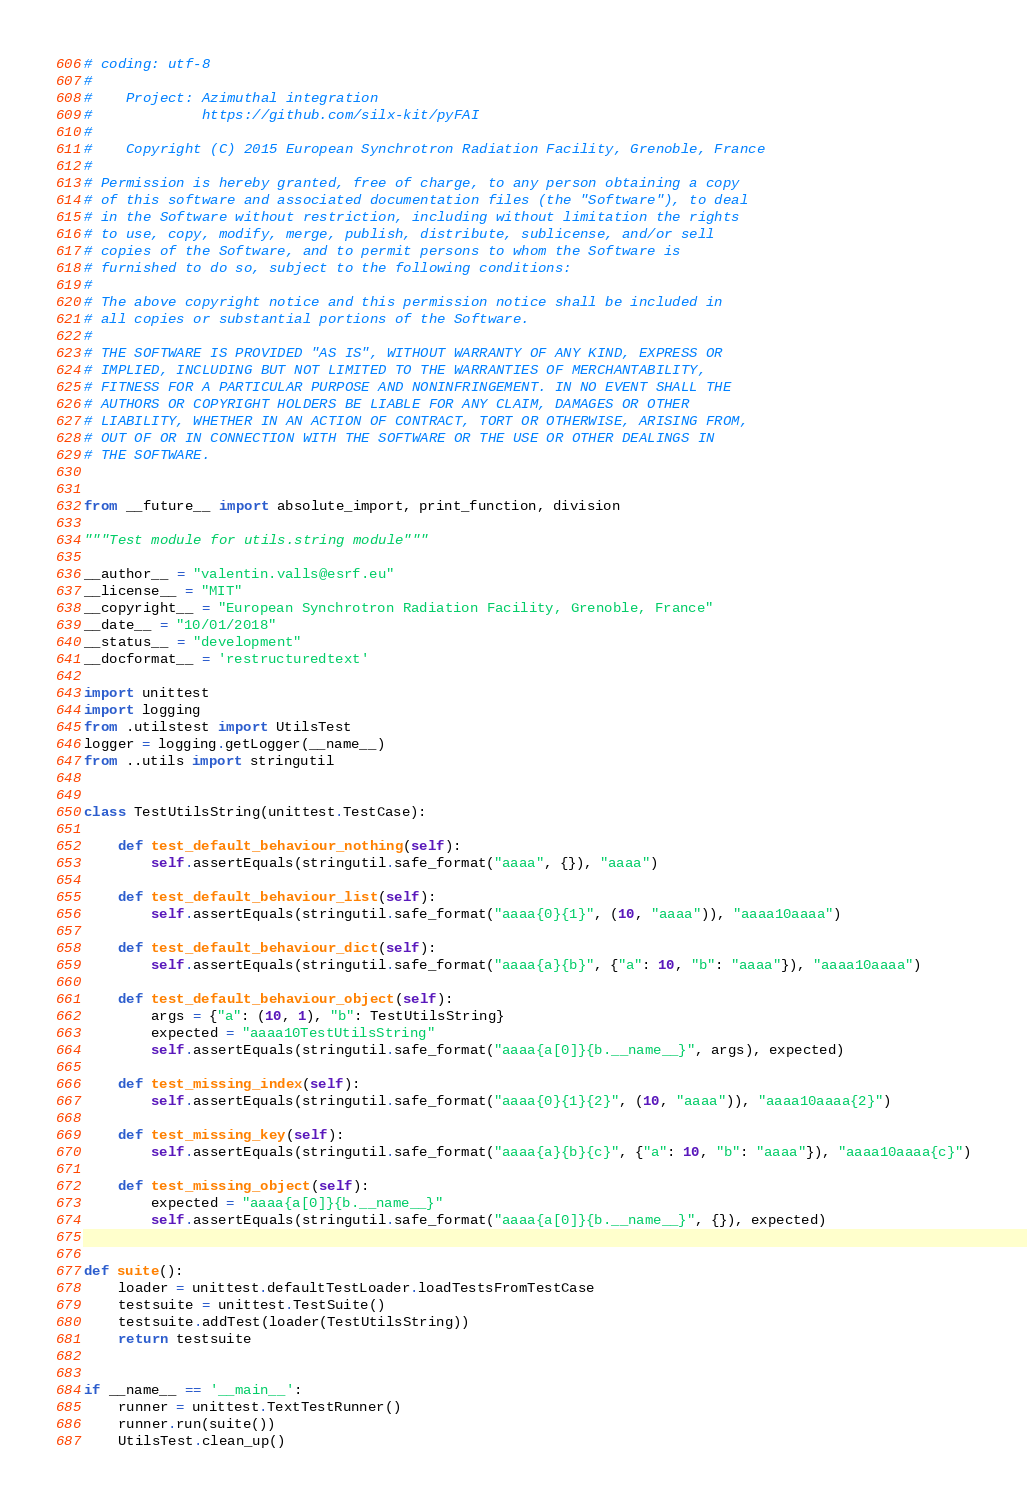Convert code to text. <code><loc_0><loc_0><loc_500><loc_500><_Python_># coding: utf-8
#
#    Project: Azimuthal integration
#             https://github.com/silx-kit/pyFAI
#
#    Copyright (C) 2015 European Synchrotron Radiation Facility, Grenoble, France
#
# Permission is hereby granted, free of charge, to any person obtaining a copy
# of this software and associated documentation files (the "Software"), to deal
# in the Software without restriction, including without limitation the rights
# to use, copy, modify, merge, publish, distribute, sublicense, and/or sell
# copies of the Software, and to permit persons to whom the Software is
# furnished to do so, subject to the following conditions:
#
# The above copyright notice and this permission notice shall be included in
# all copies or substantial portions of the Software.
#
# THE SOFTWARE IS PROVIDED "AS IS", WITHOUT WARRANTY OF ANY KIND, EXPRESS OR
# IMPLIED, INCLUDING BUT NOT LIMITED TO THE WARRANTIES OF MERCHANTABILITY,
# FITNESS FOR A PARTICULAR PURPOSE AND NONINFRINGEMENT. IN NO EVENT SHALL THE
# AUTHORS OR COPYRIGHT HOLDERS BE LIABLE FOR ANY CLAIM, DAMAGES OR OTHER
# LIABILITY, WHETHER IN AN ACTION OF CONTRACT, TORT OR OTHERWISE, ARISING FROM,
# OUT OF OR IN CONNECTION WITH THE SOFTWARE OR THE USE OR OTHER DEALINGS IN
# THE SOFTWARE.


from __future__ import absolute_import, print_function, division

"""Test module for utils.string module"""

__author__ = "valentin.valls@esrf.eu"
__license__ = "MIT"
__copyright__ = "European Synchrotron Radiation Facility, Grenoble, France"
__date__ = "10/01/2018"
__status__ = "development"
__docformat__ = 'restructuredtext'

import unittest
import logging
from .utilstest import UtilsTest
logger = logging.getLogger(__name__)
from ..utils import stringutil


class TestUtilsString(unittest.TestCase):

    def test_default_behaviour_nothing(self):
        self.assertEquals(stringutil.safe_format("aaaa", {}), "aaaa")

    def test_default_behaviour_list(self):
        self.assertEquals(stringutil.safe_format("aaaa{0}{1}", (10, "aaaa")), "aaaa10aaaa")

    def test_default_behaviour_dict(self):
        self.assertEquals(stringutil.safe_format("aaaa{a}{b}", {"a": 10, "b": "aaaa"}), "aaaa10aaaa")

    def test_default_behaviour_object(self):
        args = {"a": (10, 1), "b": TestUtilsString}
        expected = "aaaa10TestUtilsString"
        self.assertEquals(stringutil.safe_format("aaaa{a[0]}{b.__name__}", args), expected)

    def test_missing_index(self):
        self.assertEquals(stringutil.safe_format("aaaa{0}{1}{2}", (10, "aaaa")), "aaaa10aaaa{2}")

    def test_missing_key(self):
        self.assertEquals(stringutil.safe_format("aaaa{a}{b}{c}", {"a": 10, "b": "aaaa"}), "aaaa10aaaa{c}")

    def test_missing_object(self):
        expected = "aaaa{a[0]}{b.__name__}"
        self.assertEquals(stringutil.safe_format("aaaa{a[0]}{b.__name__}", {}), expected)


def suite():
    loader = unittest.defaultTestLoader.loadTestsFromTestCase
    testsuite = unittest.TestSuite()
    testsuite.addTest(loader(TestUtilsString))
    return testsuite


if __name__ == '__main__':
    runner = unittest.TextTestRunner()
    runner.run(suite())
    UtilsTest.clean_up()
</code> 